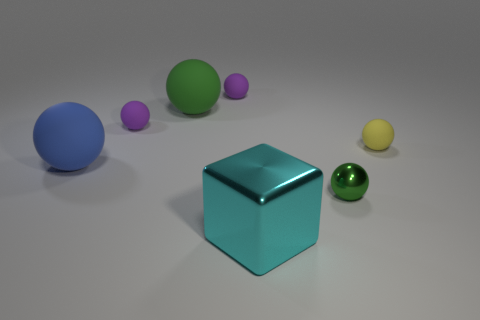Are there any other things that are the same shape as the cyan thing?
Provide a short and direct response. No. There is a green object on the left side of the green object that is right of the large block; what size is it?
Offer a terse response. Large. Is there a green metal thing that has the same size as the block?
Give a very brief answer. No. Is the size of the thing that is in front of the small green metal thing the same as the object on the right side of the green metal object?
Offer a very short reply. No. There is a big thing in front of the tiny object in front of the large blue rubber object; what shape is it?
Provide a short and direct response. Cube. What number of tiny yellow rubber objects are right of the cyan metal block?
Ensure brevity in your answer.  1. There is a big object that is the same material as the big green sphere; what is its color?
Provide a short and direct response. Blue. There is a blue sphere; is its size the same as the green matte ball that is behind the big blue thing?
Your answer should be compact. Yes. How big is the green ball that is behind the purple ball that is left of the purple object that is behind the big green ball?
Offer a very short reply. Large. What number of rubber objects are large green spheres or big blue cylinders?
Your answer should be compact. 1. 